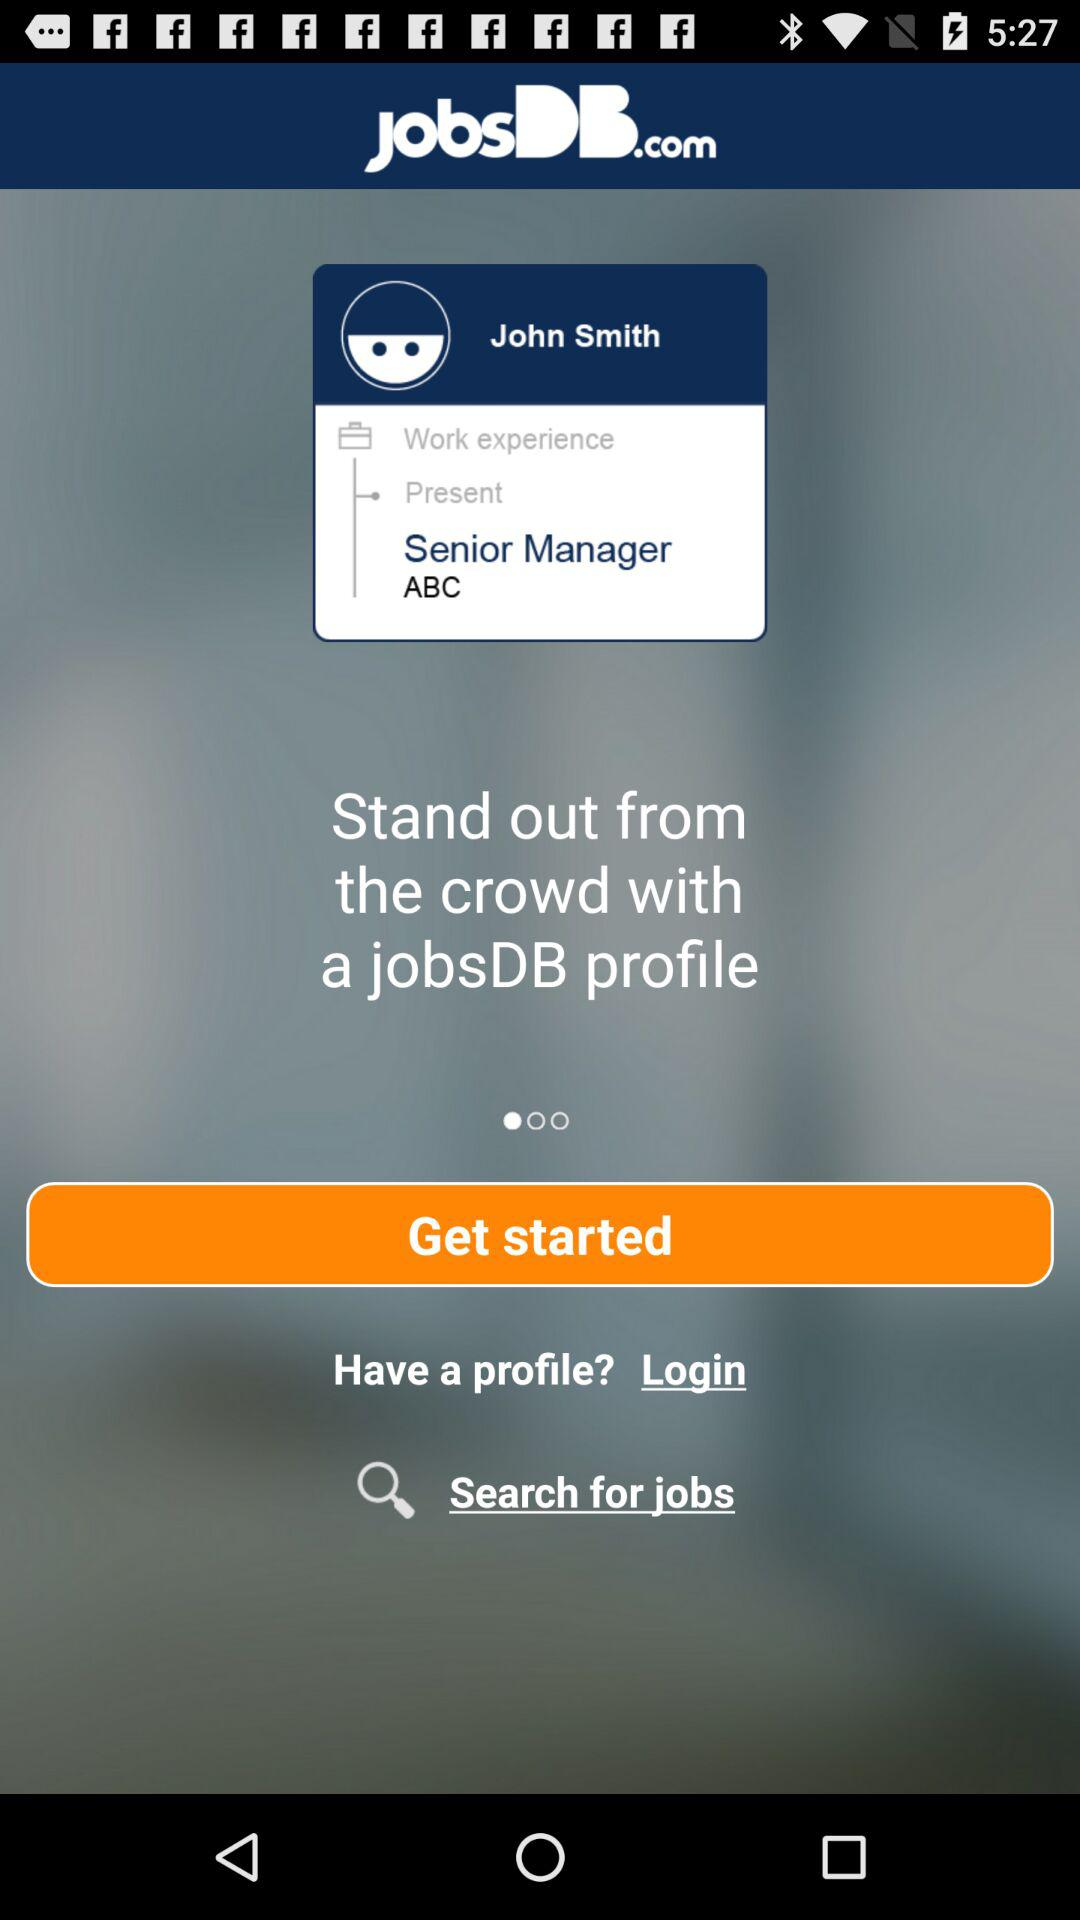What is the application name? The application name is "jobsDB.com". 